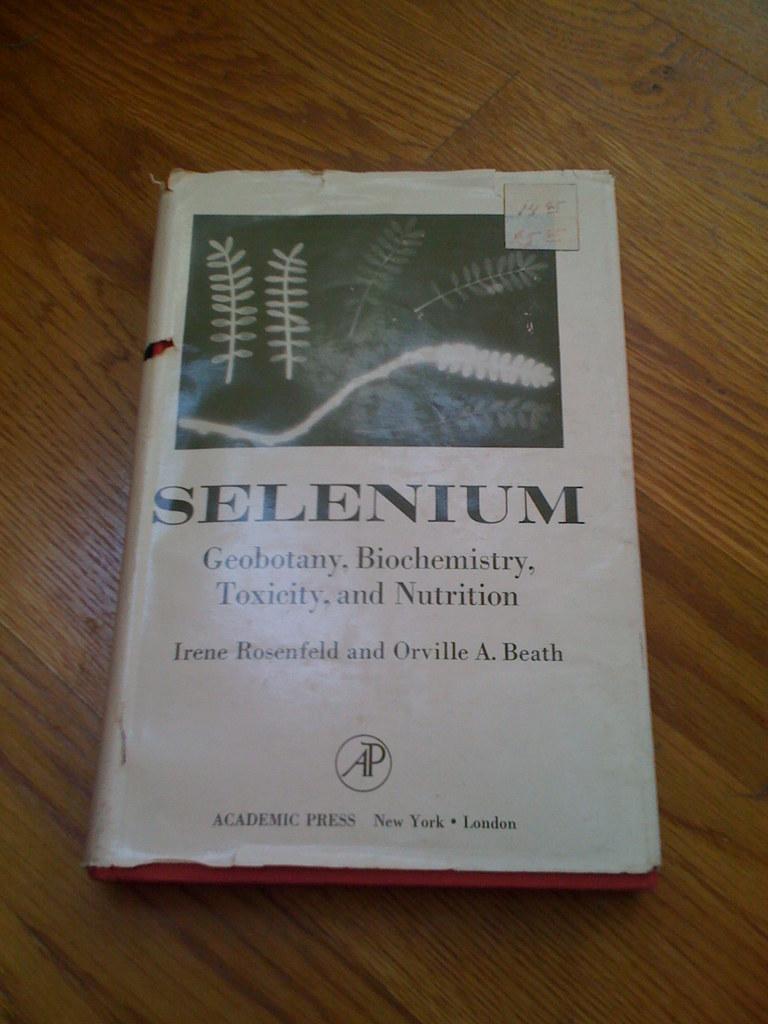What is the name of this book?
Make the answer very short. Selenium. 